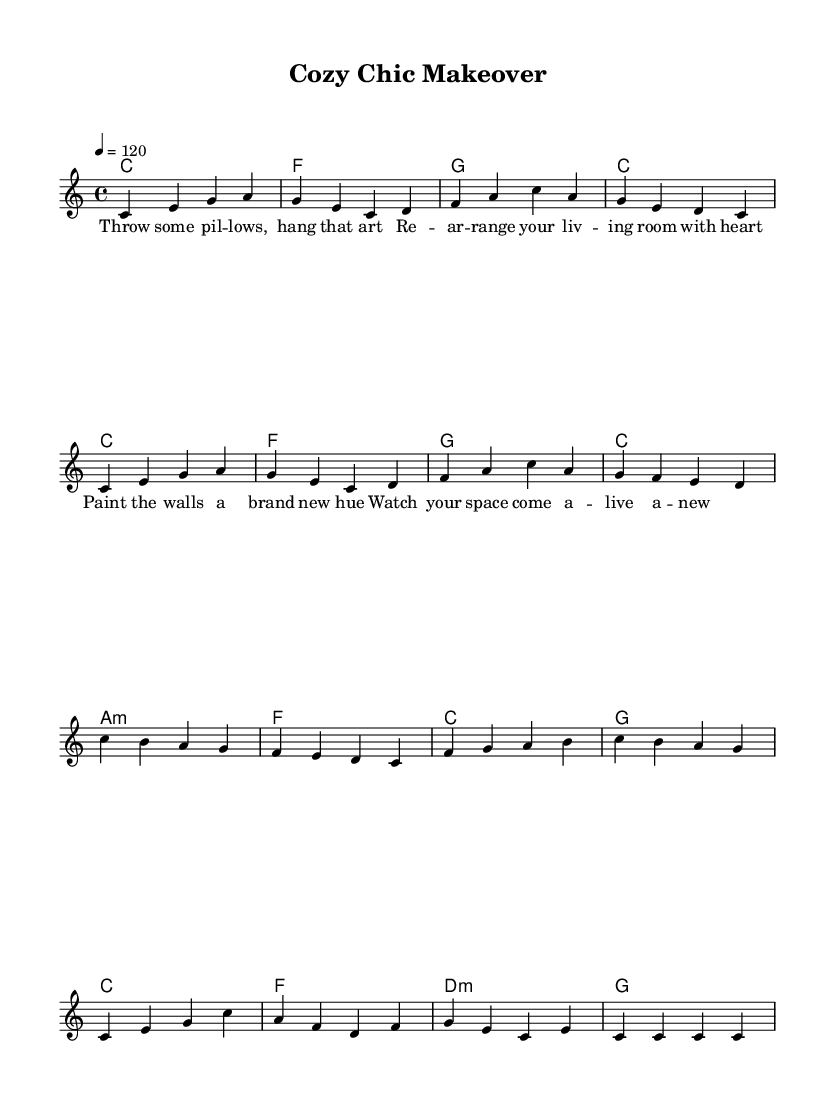What is the key signature of this music? The key signature is indicated by the initial notes and does not have any sharps or flats associated with them. In this case, the key signature is C major.
Answer: C major What is the time signature of this music? The time signature is found at the beginning of the sheet music and is expressed as a fraction. Here, it is shown as 4/4, which means there are four beats in each measure and the quarter note gets the beat.
Answer: 4/4 What is the tempo marking? The tempo marking is given in beats per minute, located above the staff. In this instance, it states 4 = 120, which means there are 120 beats per minute which corresponds to the quarter note.
Answer: 120 How many measures are there in this piece? By counting the bar lines in the melody section of the music, there are a total of 16 measures present. Each group of notes separated by a bar line represents one complete measure.
Answer: 16 Identify the predominant chord used throughout the piece. Looking at the harmony section, the chord named 'C' appears frequently in the chord progression, indicating it is the home chord for this piece.
Answer: C What is the primary lyrical theme of the song? By analyzing the lyrics, the song focuses on themes of home decorating and transformation, as indicated by phrases related to rearranging and enhancing a living space.
Answer: Home decorating 